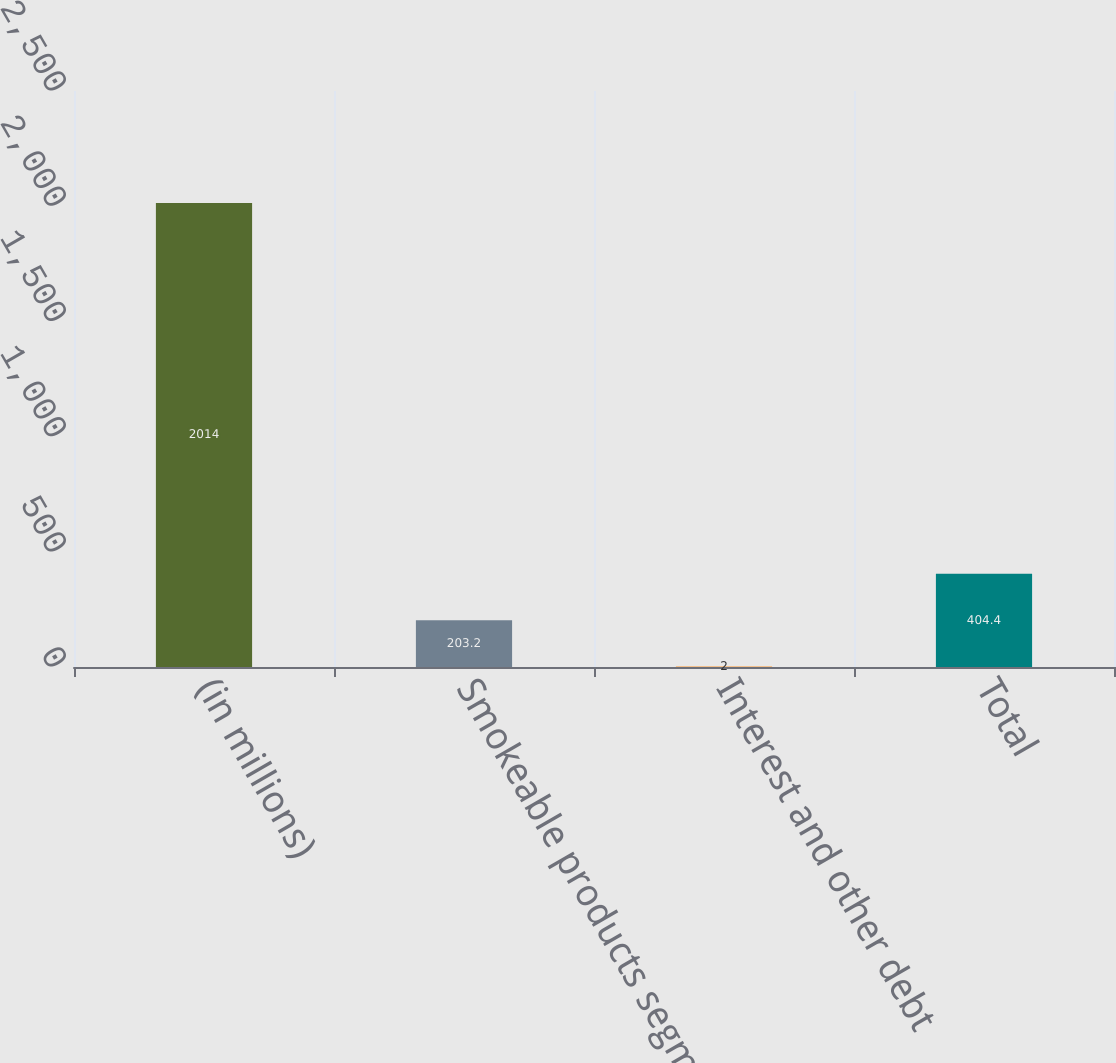<chart> <loc_0><loc_0><loc_500><loc_500><bar_chart><fcel>(in millions)<fcel>Smokeable products segment<fcel>Interest and other debt<fcel>Total<nl><fcel>2014<fcel>203.2<fcel>2<fcel>404.4<nl></chart> 